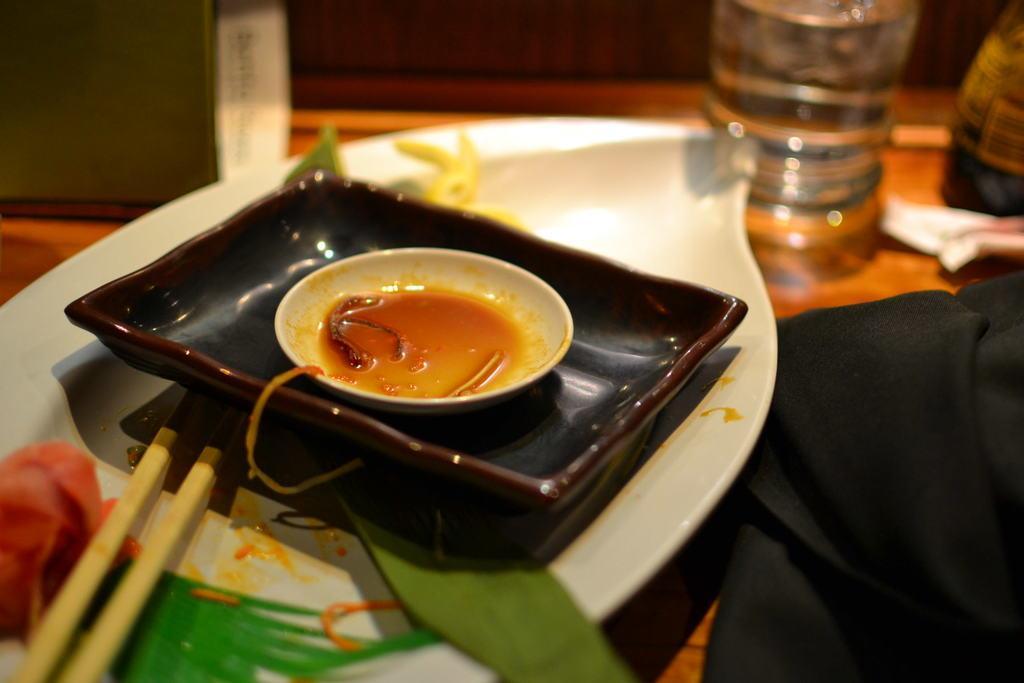Can you describe this image briefly? In this image i can see three plates, two sticks and a bottle on the table. 